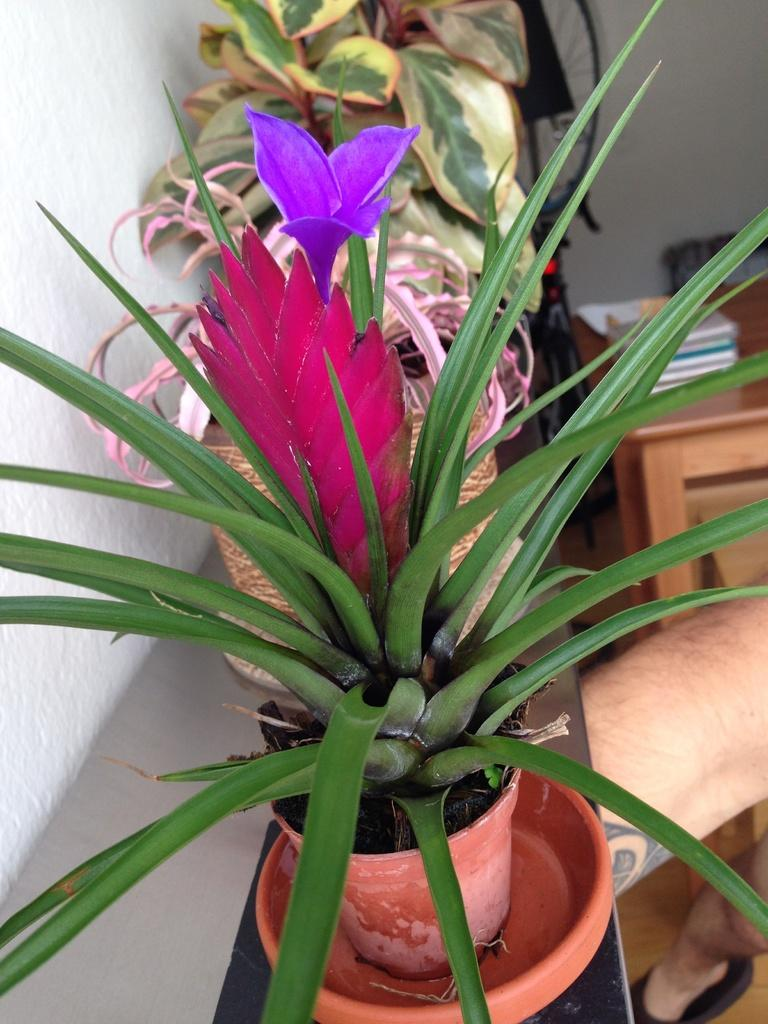What objects are on the desk in the image? There are flower pots on the desk in the image. What objects are on the table in the image? There are books on the table in the image. What type of object is on a stand in the image? There is a wheel on a stand in the image. Who or what is present in the image? There is a person in the image. What is visible in the background of the image? There is a wall in the image. What type of milk is being served to the bears in the image? There are no bears or milk present in the image. 